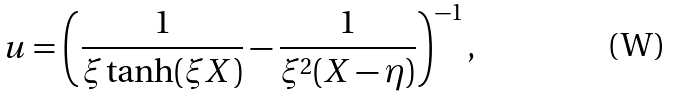Convert formula to latex. <formula><loc_0><loc_0><loc_500><loc_500>u = \left ( \frac { 1 } { \xi \tanh ( \xi X ) } - \frac { 1 } { \xi ^ { 2 } ( X - \eta ) } \right ) ^ { - 1 } ,</formula> 